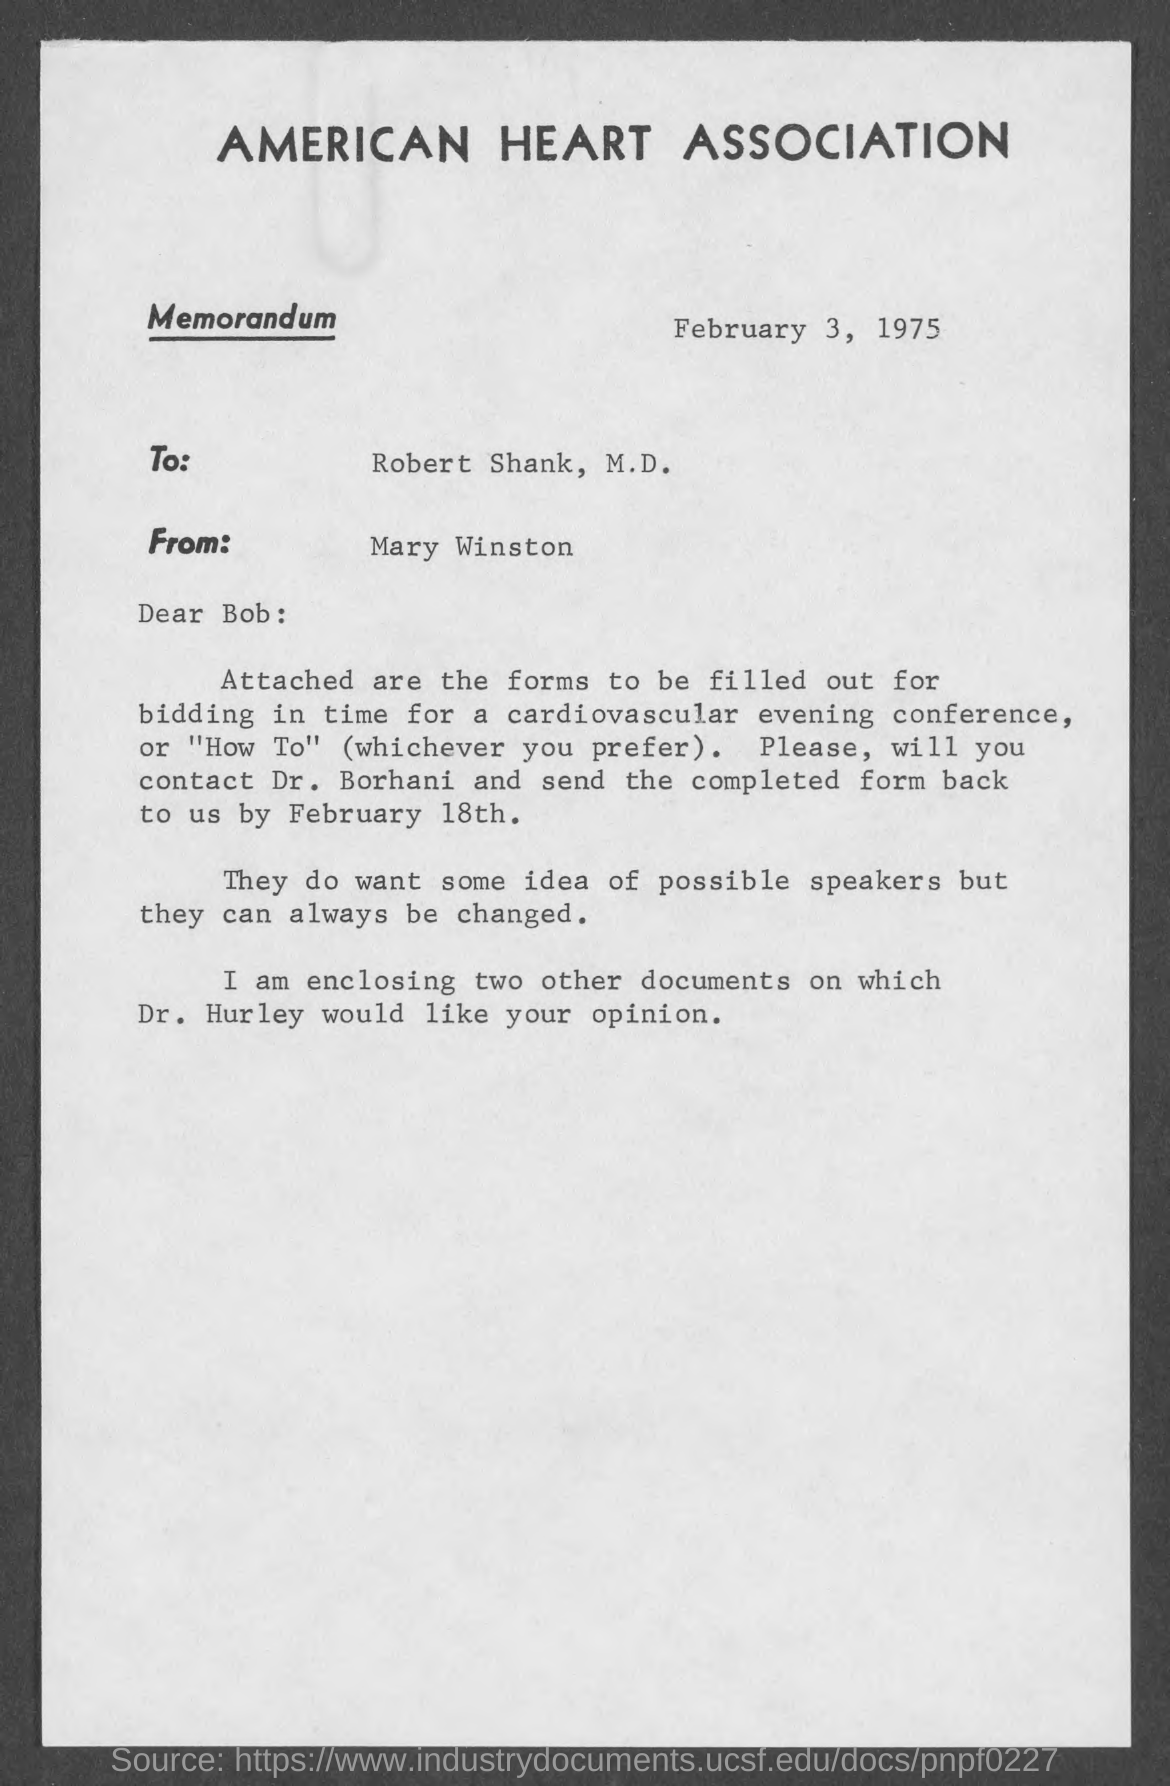Which Association is mentioned in the letterhead?
Your answer should be compact. American Heart Association. What is the date mentioned in this memorandum?
Keep it short and to the point. February 3, 1975. Who is the sender of this memorandum?
Offer a very short reply. Mary Winston. 